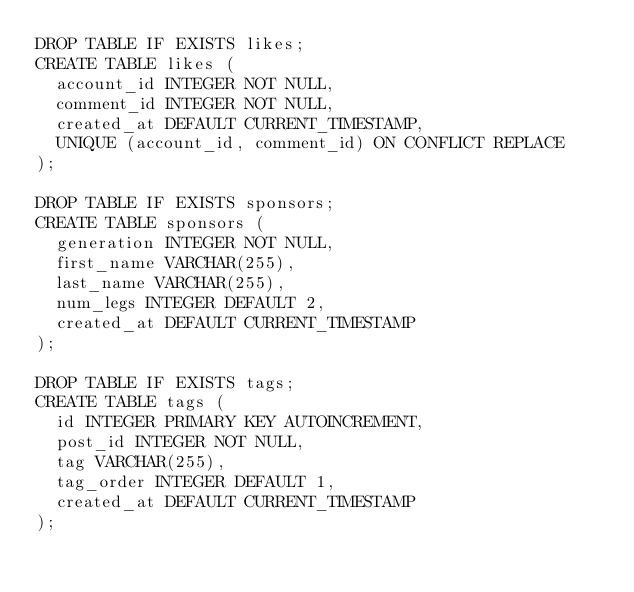<code> <loc_0><loc_0><loc_500><loc_500><_SQL_>DROP TABLE IF EXISTS likes;
CREATE TABLE likes (
  account_id INTEGER NOT NULL,
  comment_id INTEGER NOT NULL,
  created_at DEFAULT CURRENT_TIMESTAMP,
  UNIQUE (account_id, comment_id) ON CONFLICT REPLACE
);

DROP TABLE IF EXISTS sponsors;
CREATE TABLE sponsors (
  generation INTEGER NOT NULL,
  first_name VARCHAR(255),
  last_name VARCHAR(255),
  num_legs INTEGER DEFAULT 2,
  created_at DEFAULT CURRENT_TIMESTAMP
);

DROP TABLE IF EXISTS tags;
CREATE TABLE tags (
  id INTEGER PRIMARY KEY AUTOINCREMENT,
  post_id INTEGER NOT NULL,
  tag VARCHAR(255),
  tag_order INTEGER DEFAULT 1,
  created_at DEFAULT CURRENT_TIMESTAMP
);
</code> 